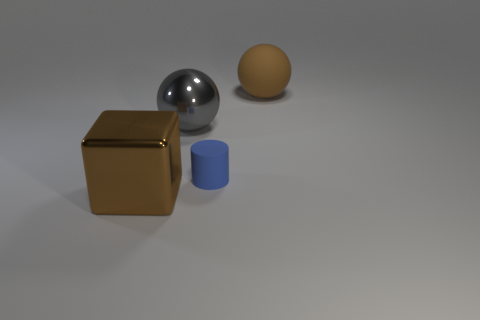Do the brown shiny cube and the matte cylinder have the same size?
Ensure brevity in your answer.  No. Are there any other things that are the same shape as the blue matte thing?
Your answer should be compact. No. Is the brown sphere made of the same material as the big brown thing left of the tiny matte thing?
Ensure brevity in your answer.  No. There is a large shiny object that is left of the gray thing; does it have the same color as the large matte sphere?
Ensure brevity in your answer.  Yes. How many objects are both left of the large brown matte object and to the right of the small cylinder?
Make the answer very short. 0. What number of other things are made of the same material as the blue cylinder?
Keep it short and to the point. 1. Are the big object in front of the gray shiny object and the blue thing made of the same material?
Make the answer very short. No. What size is the matte object that is left of the object right of the rubber cylinder in front of the gray metal object?
Offer a very short reply. Small. What number of other objects are there of the same color as the cube?
Offer a very short reply. 1. There is another matte object that is the same size as the gray object; what is its shape?
Your answer should be very brief. Sphere. 